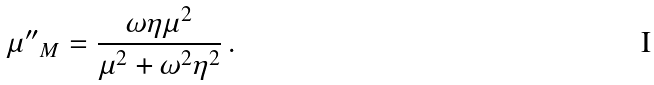<formula> <loc_0><loc_0><loc_500><loc_500>\mu { ^ { \prime \prime } } _ { M } = \frac { \omega \eta \mu ^ { 2 } } { \mu ^ { 2 } + \omega ^ { 2 } \eta ^ { 2 } } \, .</formula> 